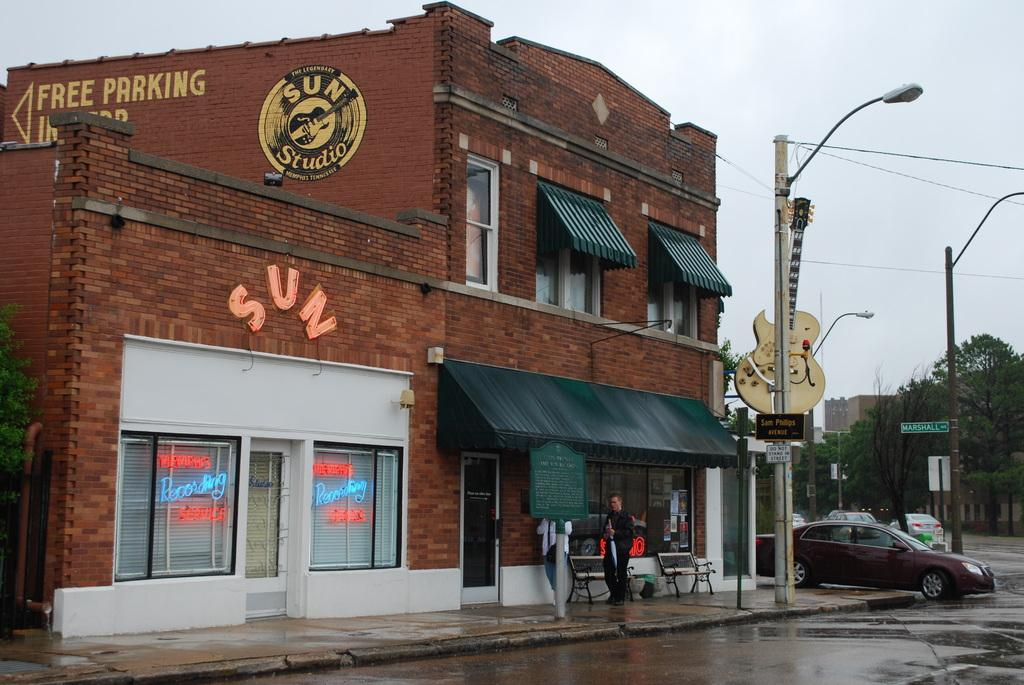<image>
Share a concise interpretation of the image provided. a building with 'free parking' drawn on the side of it 